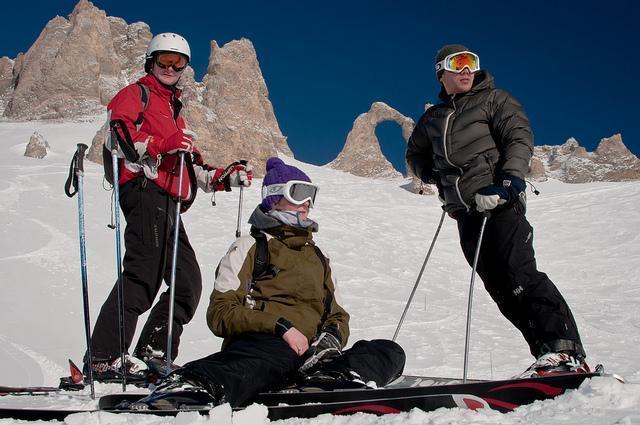What are the poles helping the man on the right do?
Select the correct answer and articulate reasoning with the following format: 'Answer: answer
Rationale: rationale.'
Options: Stand, flip, spin, clean. Answer: stand.
Rationale: The man on the right is stationary. he is not performing tricks. 